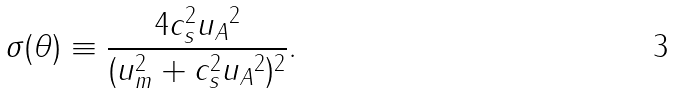<formula> <loc_0><loc_0><loc_500><loc_500>\sigma ( \theta ) \equiv \frac { 4 c _ { s } ^ { 2 } u _ { A } \| ^ { 2 } } { ( u _ { m } ^ { 2 } + c _ { s } ^ { 2 } u _ { A } \| ^ { 2 } ) ^ { 2 } } .</formula> 